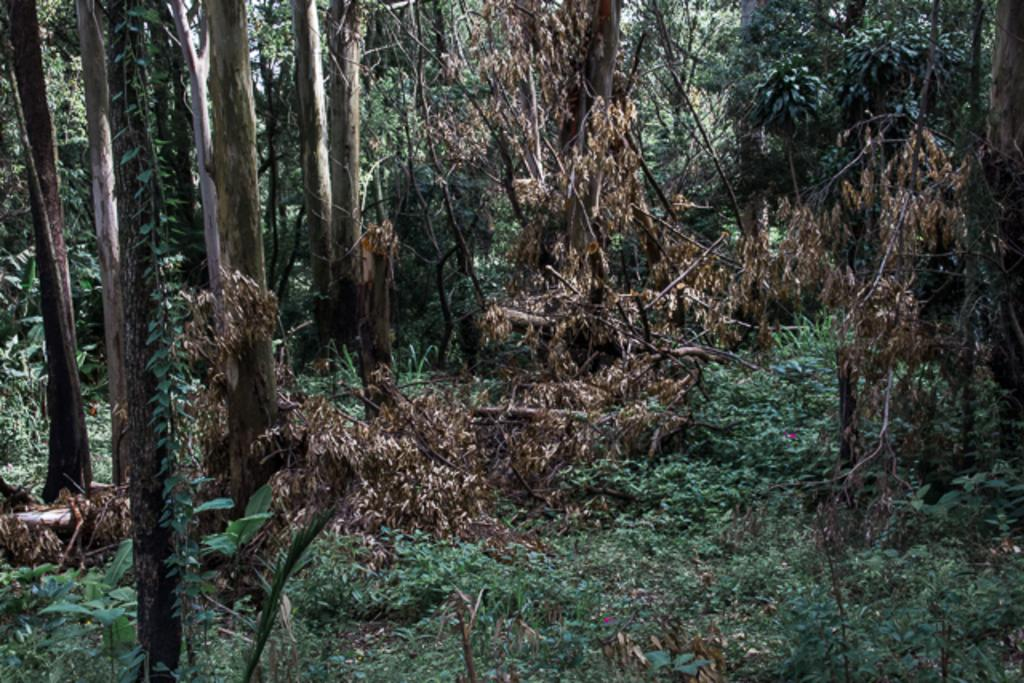What type of vegetation can be seen in the image? There are trees in the image. What is present on the ground beneath the trees? There are dry leaves in the image. What type of paper can be seen hanging from the trees in the image? There is no paper present in the image; it only features trees and dry leaves. 